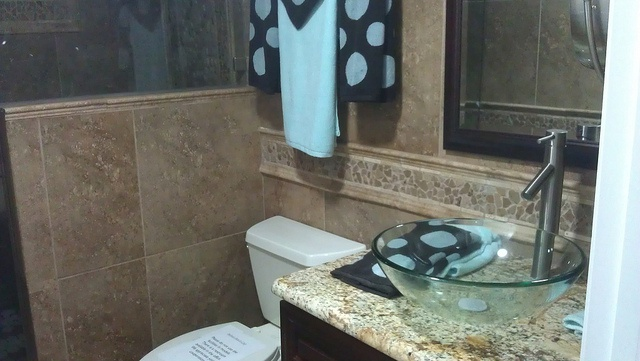Describe the objects in this image and their specific colors. I can see bowl in gray, darkgray, and purple tones, sink in gray, darkgray, and purple tones, and toilet in gray, darkgray, lightblue, and lightgray tones in this image. 